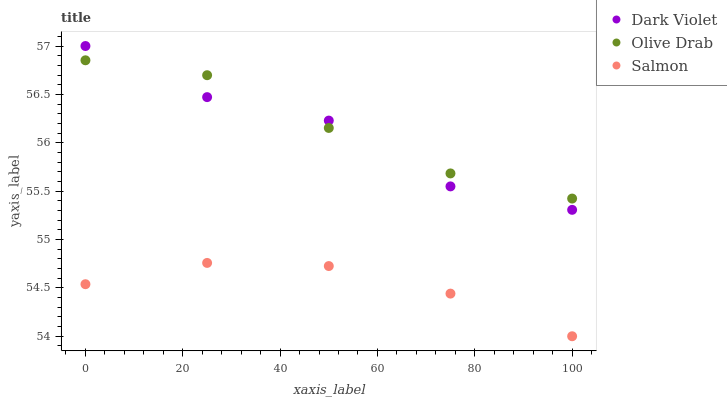Does Salmon have the minimum area under the curve?
Answer yes or no. Yes. Does Olive Drab have the maximum area under the curve?
Answer yes or no. Yes. Does Dark Violet have the minimum area under the curve?
Answer yes or no. No. Does Dark Violet have the maximum area under the curve?
Answer yes or no. No. Is Salmon the smoothest?
Answer yes or no. Yes. Is Dark Violet the roughest?
Answer yes or no. Yes. Is Olive Drab the smoothest?
Answer yes or no. No. Is Olive Drab the roughest?
Answer yes or no. No. Does Salmon have the lowest value?
Answer yes or no. Yes. Does Dark Violet have the lowest value?
Answer yes or no. No. Does Dark Violet have the highest value?
Answer yes or no. Yes. Does Olive Drab have the highest value?
Answer yes or no. No. Is Salmon less than Dark Violet?
Answer yes or no. Yes. Is Olive Drab greater than Salmon?
Answer yes or no. Yes. Does Olive Drab intersect Dark Violet?
Answer yes or no. Yes. Is Olive Drab less than Dark Violet?
Answer yes or no. No. Is Olive Drab greater than Dark Violet?
Answer yes or no. No. Does Salmon intersect Dark Violet?
Answer yes or no. No. 